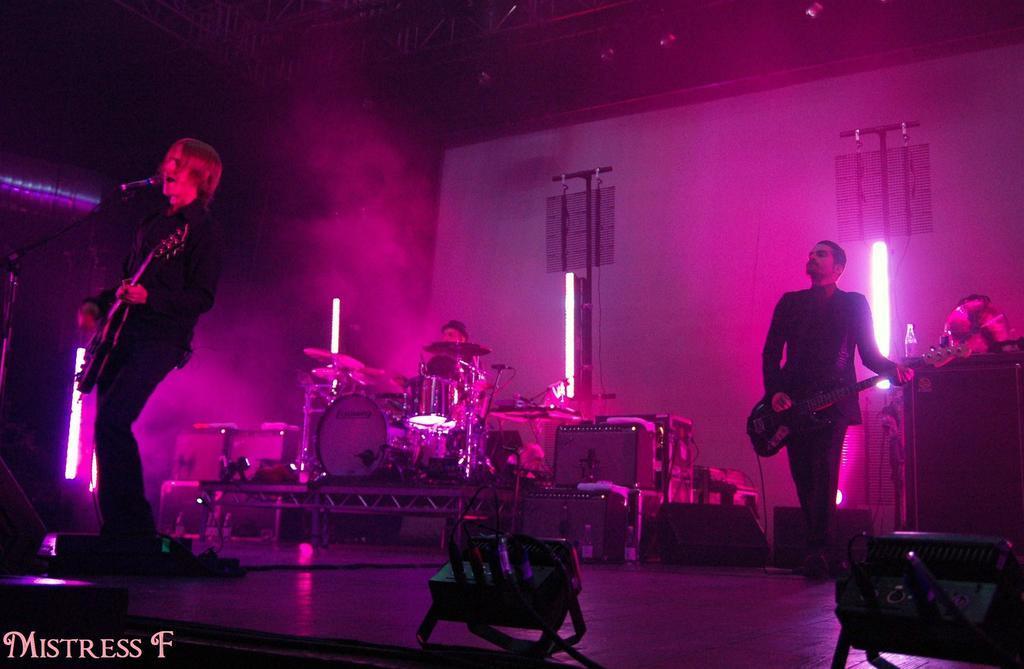Can you describe this image briefly? This man is playing guitar and singing in-front of mic. Far another person is also playing guitar. Background there are focusing lights. On this stage this person is playing these musical instruments. On floor there are speakers and devices. 